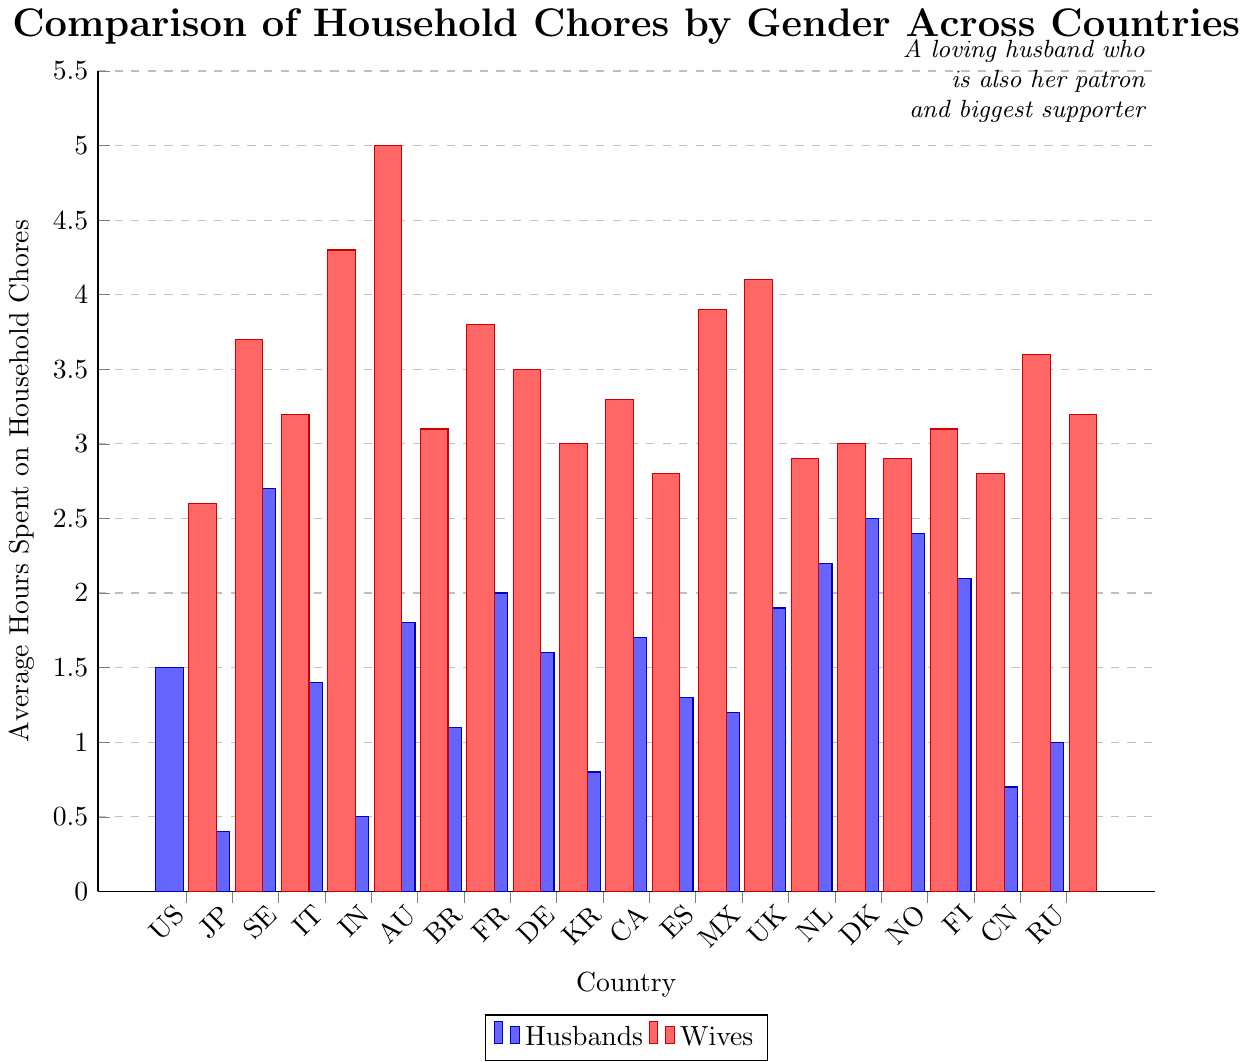Which country has the largest discrepancy in average hours spent on household chores between husbands and wives? Compare the difference in hours spent on chores between husbands and wives for all countries. The largest discrepancy is observed in India, where husbands spend 0.5 hours and wives spend 5.0 hours, resulting in a discrepancy of 4.5 hours.
Answer: India Which country has the smallest discrepancy in average hours spent on household chores between husbands and wives? Compare the difference in hours spent on chores between husbands and wives for all countries. The smallest discrepancy is observed in the United States, where husbands spend 1.5 hours and wives spend 2.6 hours, resulting in a discrepancy of 1.1 hours.
Answer: United States In which country do husbands spend the most hours on household chores, and what is that amount? Look at the bar representing husbands' hours for all countries. The highest bar for husbands is observed in Sweden, where husbands spend 2.7 hours on household chores.
Answer: Sweden, 2.7 hours Which countries have a higher average number of hours spent on household chores by husbands than Germany? Identify Germany's bar for husbands (1.6 hours). Compare this value with other countries’ bars for husbands. These countries are Sweden (2.7), Australia (1.8), France (2.0), United Kingdom (1.9), Netherlands (2.2), Denmark (2.5), Norway (2.4), and Finland (2.1).
Answer: Sweden, Australia, France, United Kingdom, Netherlands, Denmark, Norway, Finland What are the combined average hours spent on household chores by husbands and wives in Brazil? Sum the hours spent by husbands (1.1) and wives (3.8) in Brazil. The total is 1.1 + 3.8 = 4.9 hours.
Answer: 4.9 hours Which country has the highest average hours spent on household chores by wives, and what is that amount? Identify the bar representing wives' hours for all countries. The highest bar for wives is observed in India, where wives spend 5.0 hours on household chores.
Answer: India, 5.0 hours How many countries have wives spending more than 3.5 average hours on household chores? Count the number of countries where the bar for wives exceeds 3.5 hours. These countries are Japan, Italy, India, Brazil, France, Spain, Mexico, China, and Russia, so there are 9 countries in total.
Answer: 9 Which country shows the smallest difference between husbands' and wives' average hours spent on chores if wives spend more time than husbands? Find the differences between husbands' and wives' hours where wives spend more time than husbands and identify the smallest difference. The smallest difference is found in the United States, with a difference of 1.1 hours.
Answer: United States In how many countries do husbands spend less than 1 hour on average on household chores? Count the number of countries where the bar for husbands is less than 1 hour. These countries are Japan (0.4), India (0.5), South Korea (0.8), China (0.7), and Russia (1.0), so there are 5 countries in total.
Answer: 5 